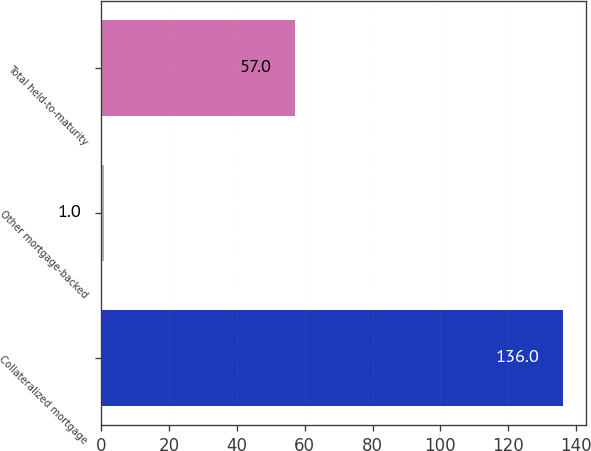Convert chart. <chart><loc_0><loc_0><loc_500><loc_500><bar_chart><fcel>Collateralized mortgage<fcel>Other mortgage-backed<fcel>Total held-to-maturity<nl><fcel>136<fcel>1<fcel>57<nl></chart> 